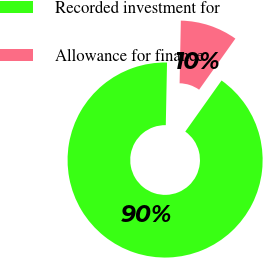Convert chart. <chart><loc_0><loc_0><loc_500><loc_500><pie_chart><fcel>Recorded investment for<fcel>Allowance for finance<nl><fcel>90.49%<fcel>9.51%<nl></chart> 